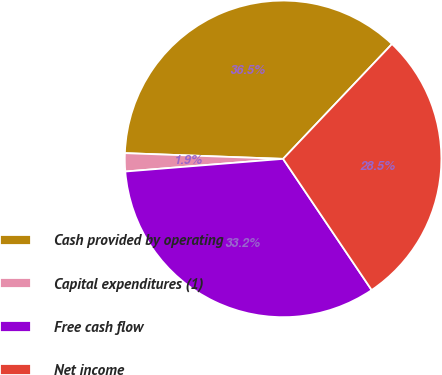<chart> <loc_0><loc_0><loc_500><loc_500><pie_chart><fcel>Cash provided by operating<fcel>Capital expenditures (1)<fcel>Free cash flow<fcel>Net income<nl><fcel>36.5%<fcel>1.85%<fcel>33.18%<fcel>28.47%<nl></chart> 